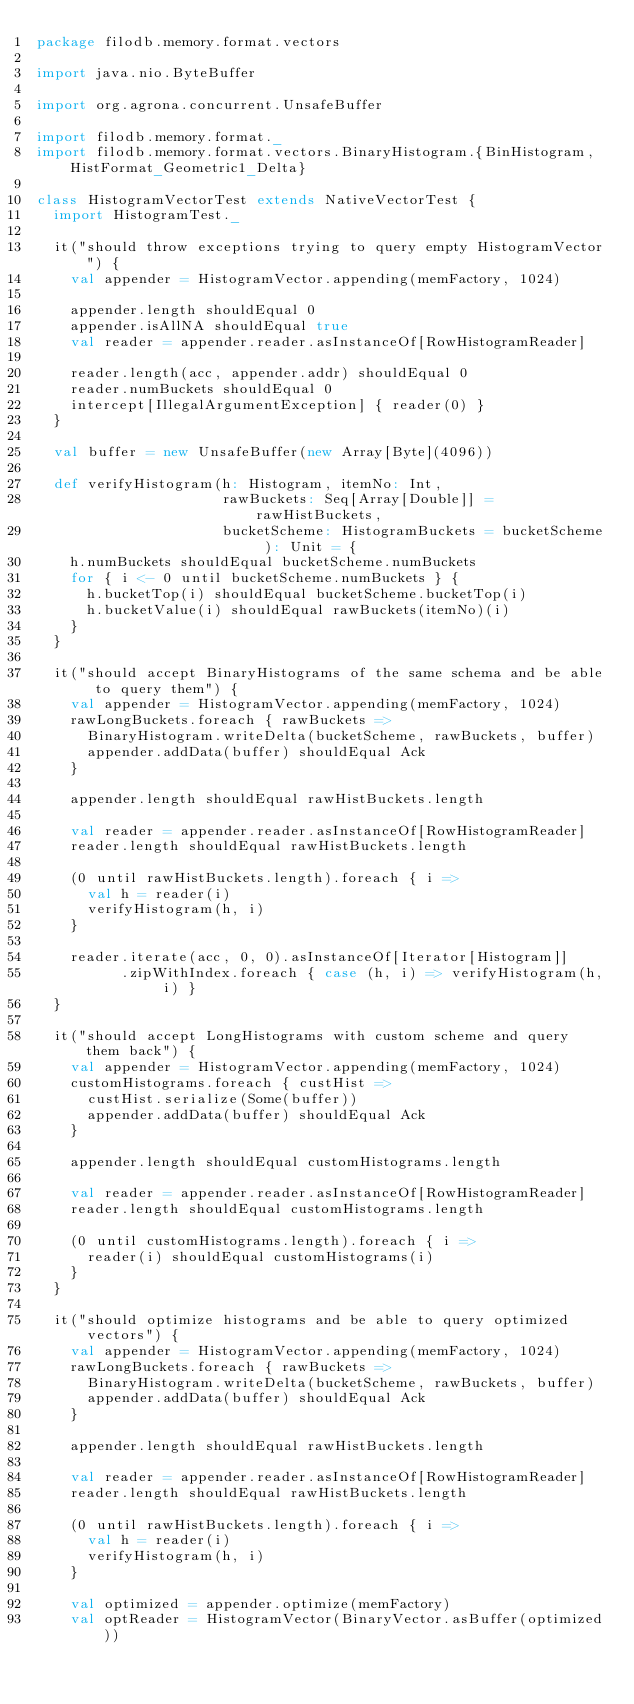Convert code to text. <code><loc_0><loc_0><loc_500><loc_500><_Scala_>package filodb.memory.format.vectors

import java.nio.ByteBuffer

import org.agrona.concurrent.UnsafeBuffer

import filodb.memory.format._
import filodb.memory.format.vectors.BinaryHistogram.{BinHistogram, HistFormat_Geometric1_Delta}

class HistogramVectorTest extends NativeVectorTest {
  import HistogramTest._

  it("should throw exceptions trying to query empty HistogramVector") {
    val appender = HistogramVector.appending(memFactory, 1024)

    appender.length shouldEqual 0
    appender.isAllNA shouldEqual true
    val reader = appender.reader.asInstanceOf[RowHistogramReader]

    reader.length(acc, appender.addr) shouldEqual 0
    reader.numBuckets shouldEqual 0
    intercept[IllegalArgumentException] { reader(0) }
  }

  val buffer = new UnsafeBuffer(new Array[Byte](4096))

  def verifyHistogram(h: Histogram, itemNo: Int,
                      rawBuckets: Seq[Array[Double]] = rawHistBuckets,
                      bucketScheme: HistogramBuckets = bucketScheme ): Unit = {
    h.numBuckets shouldEqual bucketScheme.numBuckets
    for { i <- 0 until bucketScheme.numBuckets } {
      h.bucketTop(i) shouldEqual bucketScheme.bucketTop(i)
      h.bucketValue(i) shouldEqual rawBuckets(itemNo)(i)
    }
  }

  it("should accept BinaryHistograms of the same schema and be able to query them") {
    val appender = HistogramVector.appending(memFactory, 1024)
    rawLongBuckets.foreach { rawBuckets =>
      BinaryHistogram.writeDelta(bucketScheme, rawBuckets, buffer)
      appender.addData(buffer) shouldEqual Ack
    }

    appender.length shouldEqual rawHistBuckets.length

    val reader = appender.reader.asInstanceOf[RowHistogramReader]
    reader.length shouldEqual rawHistBuckets.length

    (0 until rawHistBuckets.length).foreach { i =>
      val h = reader(i)
      verifyHistogram(h, i)
    }

    reader.iterate(acc, 0, 0).asInstanceOf[Iterator[Histogram]]
          .zipWithIndex.foreach { case (h, i) => verifyHistogram(h, i) }
  }

  it("should accept LongHistograms with custom scheme and query them back") {
    val appender = HistogramVector.appending(memFactory, 1024)
    customHistograms.foreach { custHist =>
      custHist.serialize(Some(buffer))
      appender.addData(buffer) shouldEqual Ack
    }

    appender.length shouldEqual customHistograms.length

    val reader = appender.reader.asInstanceOf[RowHistogramReader]
    reader.length shouldEqual customHistograms.length

    (0 until customHistograms.length).foreach { i =>
      reader(i) shouldEqual customHistograms(i)
    }
  }

  it("should optimize histograms and be able to query optimized vectors") {
    val appender = HistogramVector.appending(memFactory, 1024)
    rawLongBuckets.foreach { rawBuckets =>
      BinaryHistogram.writeDelta(bucketScheme, rawBuckets, buffer)
      appender.addData(buffer) shouldEqual Ack
    }

    appender.length shouldEqual rawHistBuckets.length

    val reader = appender.reader.asInstanceOf[RowHistogramReader]
    reader.length shouldEqual rawHistBuckets.length

    (0 until rawHistBuckets.length).foreach { i =>
      val h = reader(i)
      verifyHistogram(h, i)
    }

    val optimized = appender.optimize(memFactory)
    val optReader = HistogramVector(BinaryVector.asBuffer(optimized))</code> 